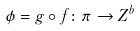<formula> <loc_0><loc_0><loc_500><loc_500>\phi = g \circ f \colon \pi \rightarrow Z ^ { b }</formula> 